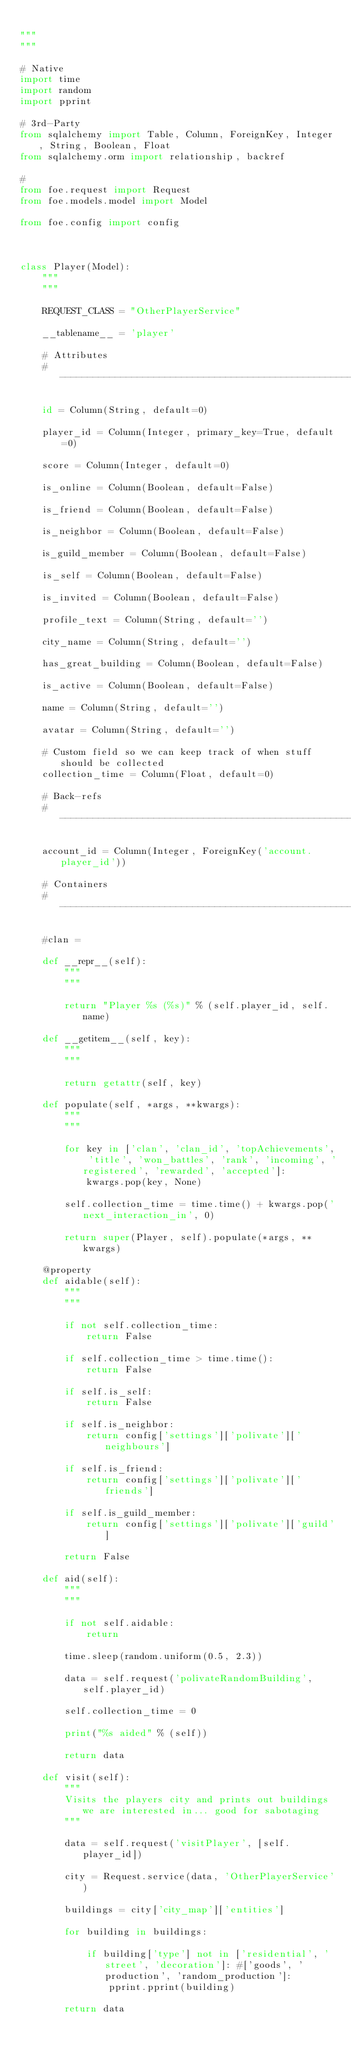<code> <loc_0><loc_0><loc_500><loc_500><_Python_>
"""
"""

# Native
import time
import random
import pprint

# 3rd-Party
from sqlalchemy import Table, Column, ForeignKey, Integer, String, Boolean, Float
from sqlalchemy.orm import relationship, backref

#
from foe.request import Request
from foe.models.model import Model

from foe.config import config



class Player(Model):
    """
    """

    REQUEST_CLASS = "OtherPlayerService"

    __tablename__ = 'player'

    # Attributes
    # ---------------------------------------------------------

    id = Column(String, default=0)

    player_id = Column(Integer, primary_key=True, default=0)

    score = Column(Integer, default=0)

    is_online = Column(Boolean, default=False)

    is_friend = Column(Boolean, default=False)

    is_neighbor = Column(Boolean, default=False)

    is_guild_member = Column(Boolean, default=False)

    is_self = Column(Boolean, default=False)

    is_invited = Column(Boolean, default=False)

    profile_text = Column(String, default='')

    city_name = Column(String, default='')

    has_great_building = Column(Boolean, default=False)

    is_active = Column(Boolean, default=False)

    name = Column(String, default='')

    avatar = Column(String, default='')

    # Custom field so we can keep track of when stuff should be collected
    collection_time = Column(Float, default=0)

    # Back-refs
    # ---------------------------------------------------------

    account_id = Column(Integer, ForeignKey('account.player_id'))

    # Containers
    # ---------------------------------------------------------

    #clan =

    def __repr__(self):
        """
        """

        return "Player %s (%s)" % (self.player_id, self.name)

    def __getitem__(self, key):
        """
        """

        return getattr(self, key)        

    def populate(self, *args, **kwargs):
        """
        """

        for key in ['clan', 'clan_id', 'topAchievements', 'title', 'won_battles', 'rank', 'incoming', 'registered', 'rewarded', 'accepted']:
            kwargs.pop(key, None)

        self.collection_time = time.time() + kwargs.pop('next_interaction_in', 0)

        return super(Player, self).populate(*args, **kwargs)

    @property
    def aidable(self):
        """
        """

        if not self.collection_time:
            return False

        if self.collection_time > time.time():
            return False

        if self.is_self:
            return False

        if self.is_neighbor:
            return config['settings']['polivate']['neighbours']

        if self.is_friend:
            return config['settings']['polivate']['friends']

        if self.is_guild_member:
            return config['settings']['polivate']['guild']

        return False

    def aid(self):
        """
        """

        if not self.aidable:
            return

        time.sleep(random.uniform(0.5, 2.3))

        data = self.request('polivateRandomBuilding', self.player_id)

        self.collection_time = 0

        print("%s aided" % (self))

        return data

    def visit(self):
        """
        Visits the players city and prints out buildings we are interested in... good for sabotaging
        """

        data = self.request('visitPlayer', [self.player_id])

        city = Request.service(data, 'OtherPlayerService')

        buildings = city['city_map']['entities']

        for building in buildings:

            if building['type'] not in ['residential', 'street', 'decoration']: #['goods', 'production', 'random_production']:
                pprint.pprint(building)

        return data
</code> 